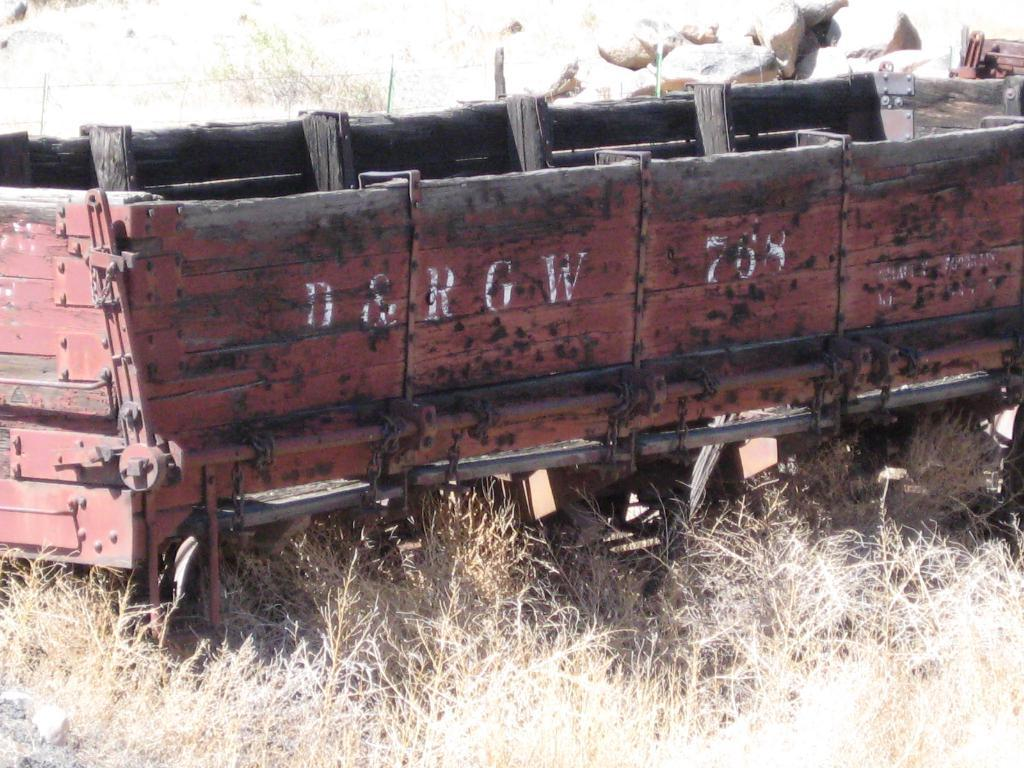What is the main subject in the center of the image? There is a trolley in the center of the image. What type of terrain is visible at the bottom of the image? There is grass at the bottom of the image. What can be seen in the background of the image? There are rocks in the background of the image. Is the coal burning hot in the image? There is no coal present in the image, so it cannot be determined if it is burning hot. 